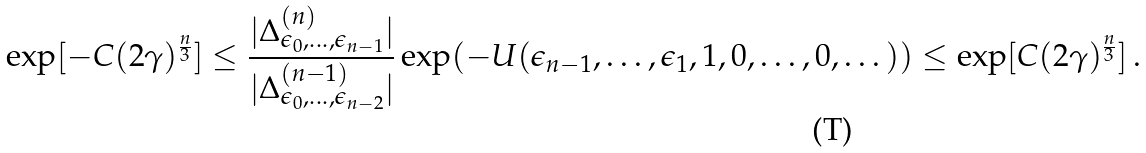<formula> <loc_0><loc_0><loc_500><loc_500>\exp [ - C ( 2 \gamma ) ^ { \frac { n } { 3 } } ] \leq \frac { | \Delta ^ { ( n ) } _ { \epsilon _ { 0 } , \dots , \epsilon _ { n - 1 } } | } { | \Delta ^ { ( n - 1 ) } _ { \epsilon _ { 0 } , \dots , \epsilon _ { n - 2 } } | } \exp ( - U ( \epsilon _ { n - 1 } , \dots , \epsilon _ { 1 } , 1 , 0 , \dots , 0 , \dots ) ) \leq \exp [ C ( 2 \gamma ) ^ { \frac { n } { 3 } } ] \, .</formula> 